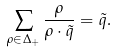Convert formula to latex. <formula><loc_0><loc_0><loc_500><loc_500>\sum _ { \rho \in \Delta _ { + } } { \frac { \rho } { \rho \cdot \tilde { q } } } = \tilde { q } .</formula> 